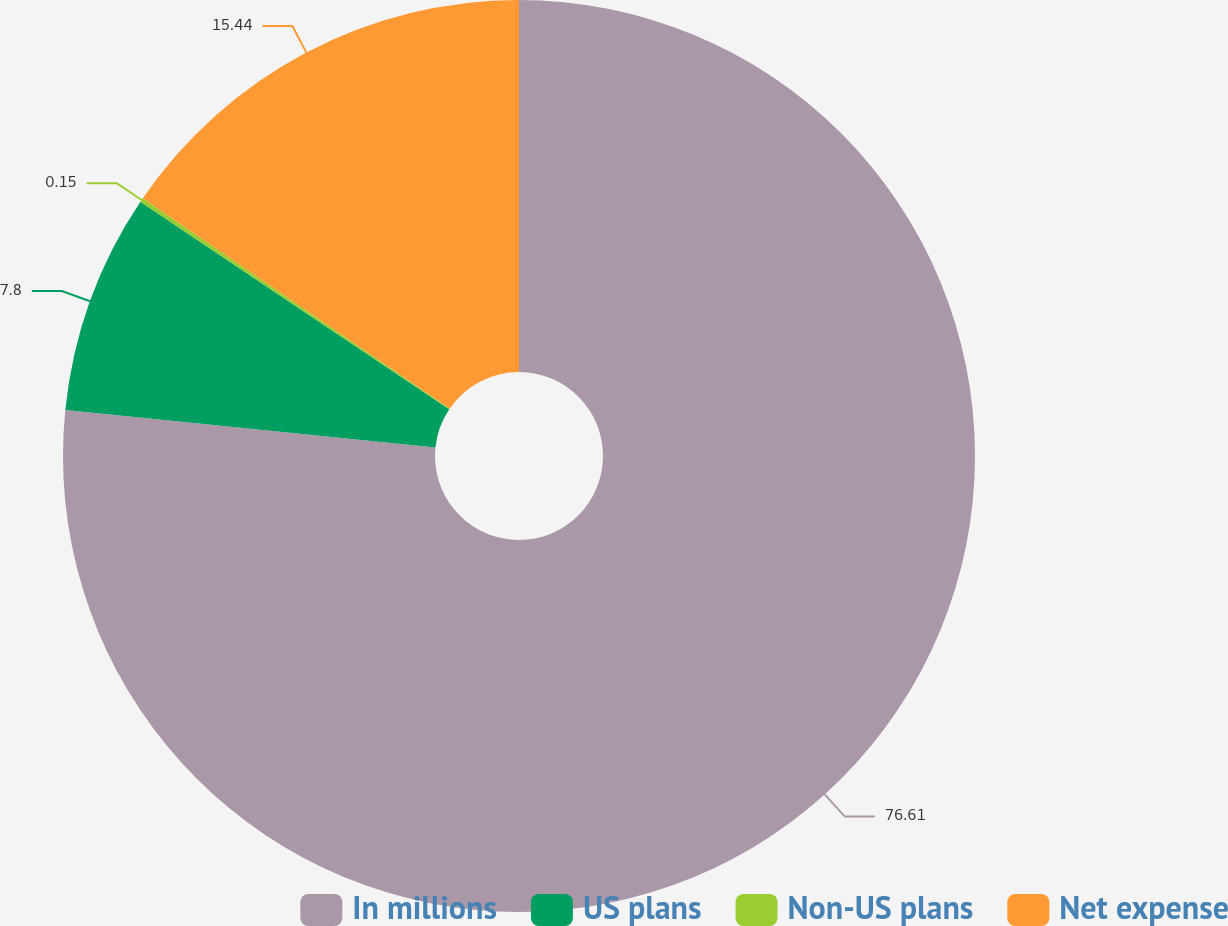Convert chart to OTSL. <chart><loc_0><loc_0><loc_500><loc_500><pie_chart><fcel>In millions<fcel>US plans<fcel>Non-US plans<fcel>Net expense<nl><fcel>76.61%<fcel>7.8%<fcel>0.15%<fcel>15.44%<nl></chart> 